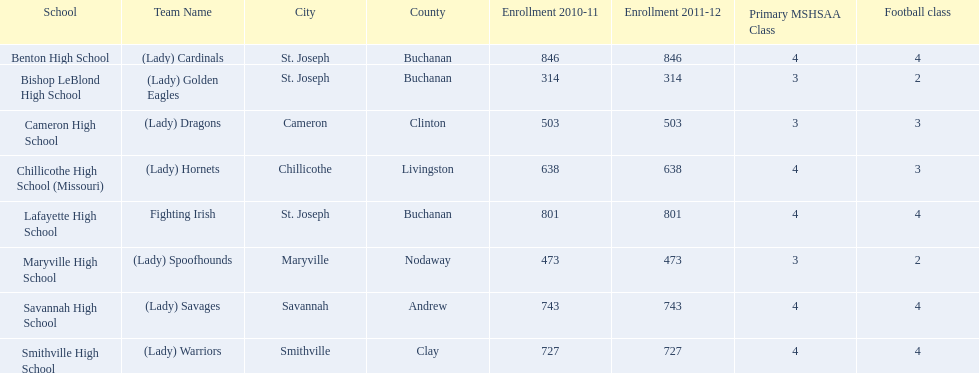What are the names of the schools? Benton High School, Bishop LeBlond High School, Cameron High School, Chillicothe High School (Missouri), Lafayette High School, Maryville High School, Savannah High School, Smithville High School. Of those, which had a total enrollment of less than 500? Bishop LeBlond High School, Maryville High School. And of those, which had the lowest enrollment? Bishop LeBlond High School. 